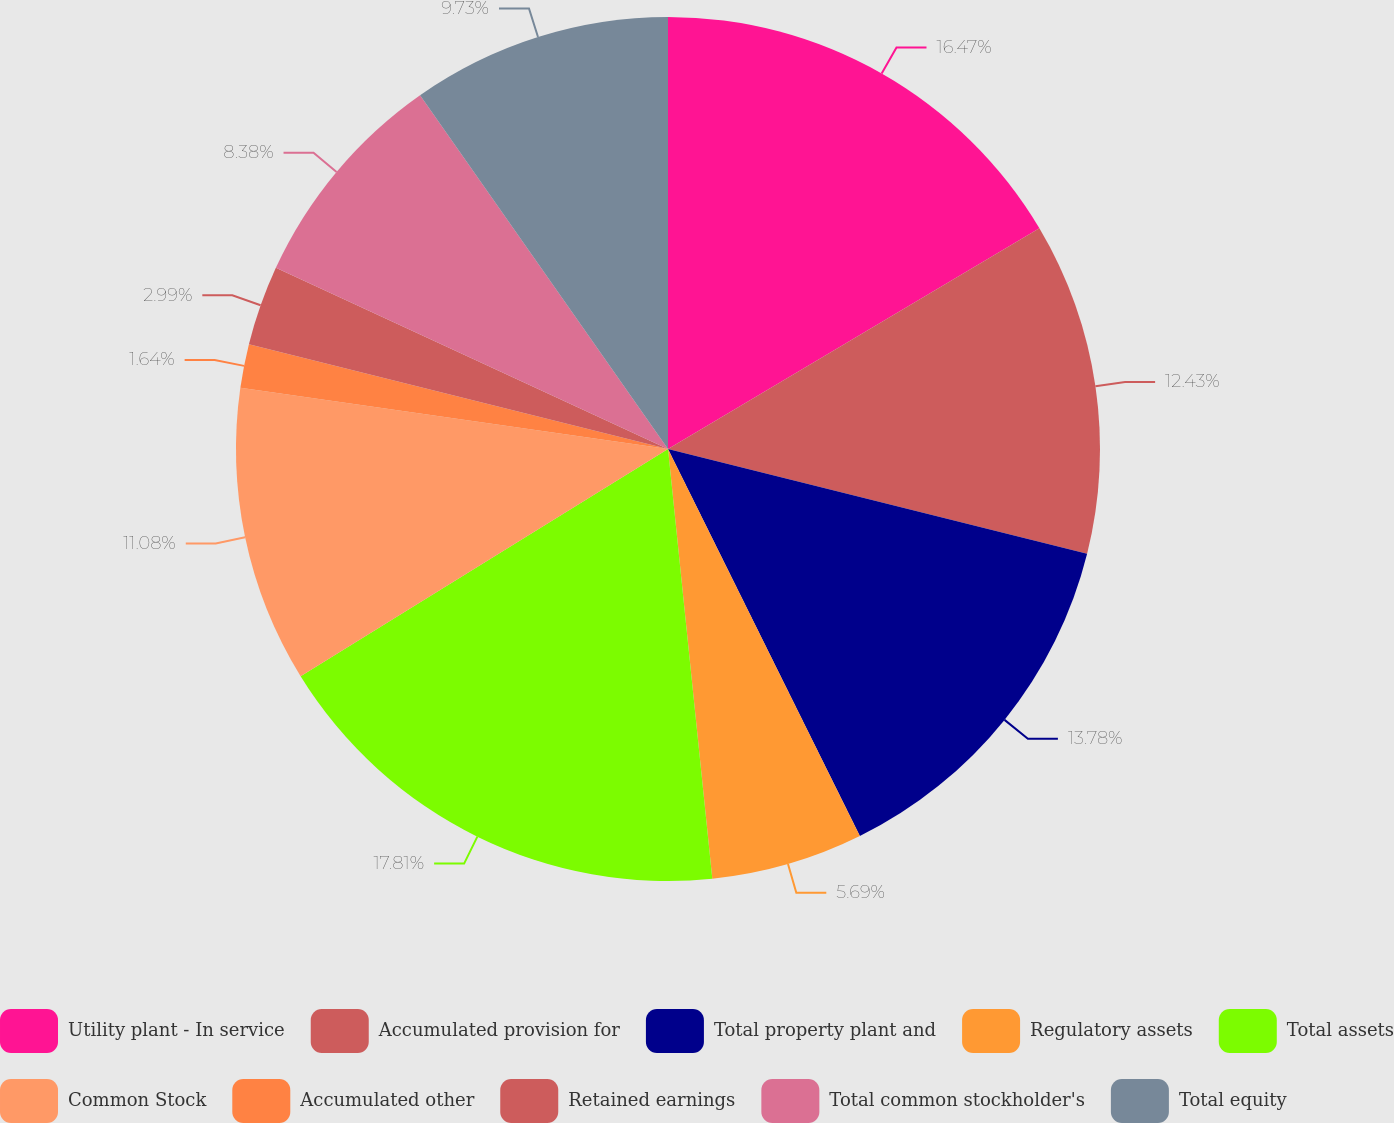Convert chart to OTSL. <chart><loc_0><loc_0><loc_500><loc_500><pie_chart><fcel>Utility plant - In service<fcel>Accumulated provision for<fcel>Total property plant and<fcel>Regulatory assets<fcel>Total assets<fcel>Common Stock<fcel>Accumulated other<fcel>Retained earnings<fcel>Total common stockholder's<fcel>Total equity<nl><fcel>16.47%<fcel>12.43%<fcel>13.78%<fcel>5.69%<fcel>17.82%<fcel>11.08%<fcel>1.64%<fcel>2.99%<fcel>8.38%<fcel>9.73%<nl></chart> 